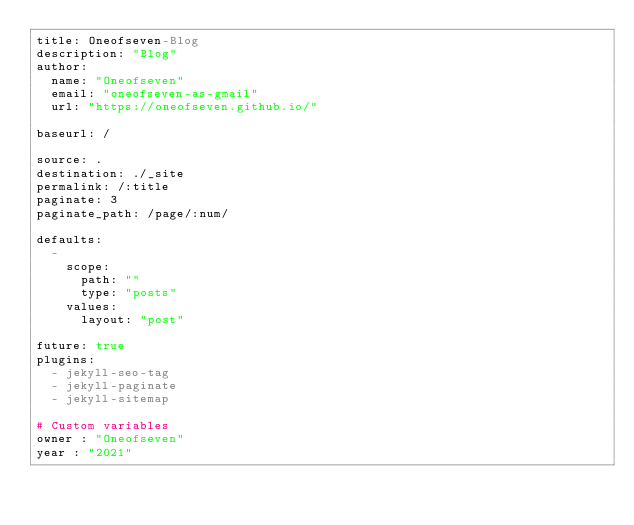<code> <loc_0><loc_0><loc_500><loc_500><_YAML_>title: Oneofseven-Blog
description: "Blog"
author:
  name: "Oneofseven"
  email: "oneofseven-as-gmail"
  url: "https://oneofseven.github.io/"

baseurl: /

source: .
destination: ./_site
permalink: /:title
paginate: 3
paginate_path: /page/:num/

defaults:
  -
    scope:
      path: ""
      type: "posts"
    values:
      layout: "post"

future: true
plugins:
  - jekyll-seo-tag
  - jekyll-paginate
  - jekyll-sitemap

# Custom variables
owner : "Oneofseven"
year : "2021"
</code> 